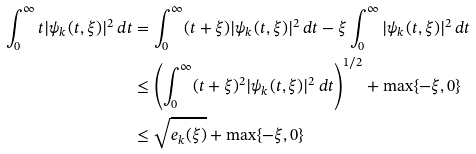Convert formula to latex. <formula><loc_0><loc_0><loc_500><loc_500>\int _ { 0 } ^ { \infty } t | \psi _ { k } ( t , \xi ) | ^ { 2 } \, d t & = \int _ { 0 } ^ { \infty } ( t + \xi ) | \psi _ { k } ( t , \xi ) | ^ { 2 } \, d t - \xi \int _ { 0 } ^ { \infty } | \psi _ { k } ( t , \xi ) | ^ { 2 } \, d t \\ & \leq \left ( \int _ { 0 } ^ { \infty } ( t + \xi ) ^ { 2 } | \psi _ { k } ( t , \xi ) | ^ { 2 } \, d t \right ) ^ { 1 / 2 } + \max \{ - \xi , 0 \} \\ & \leq \sqrt { e _ { k } ( \xi ) } + \max \{ - \xi , 0 \}</formula> 